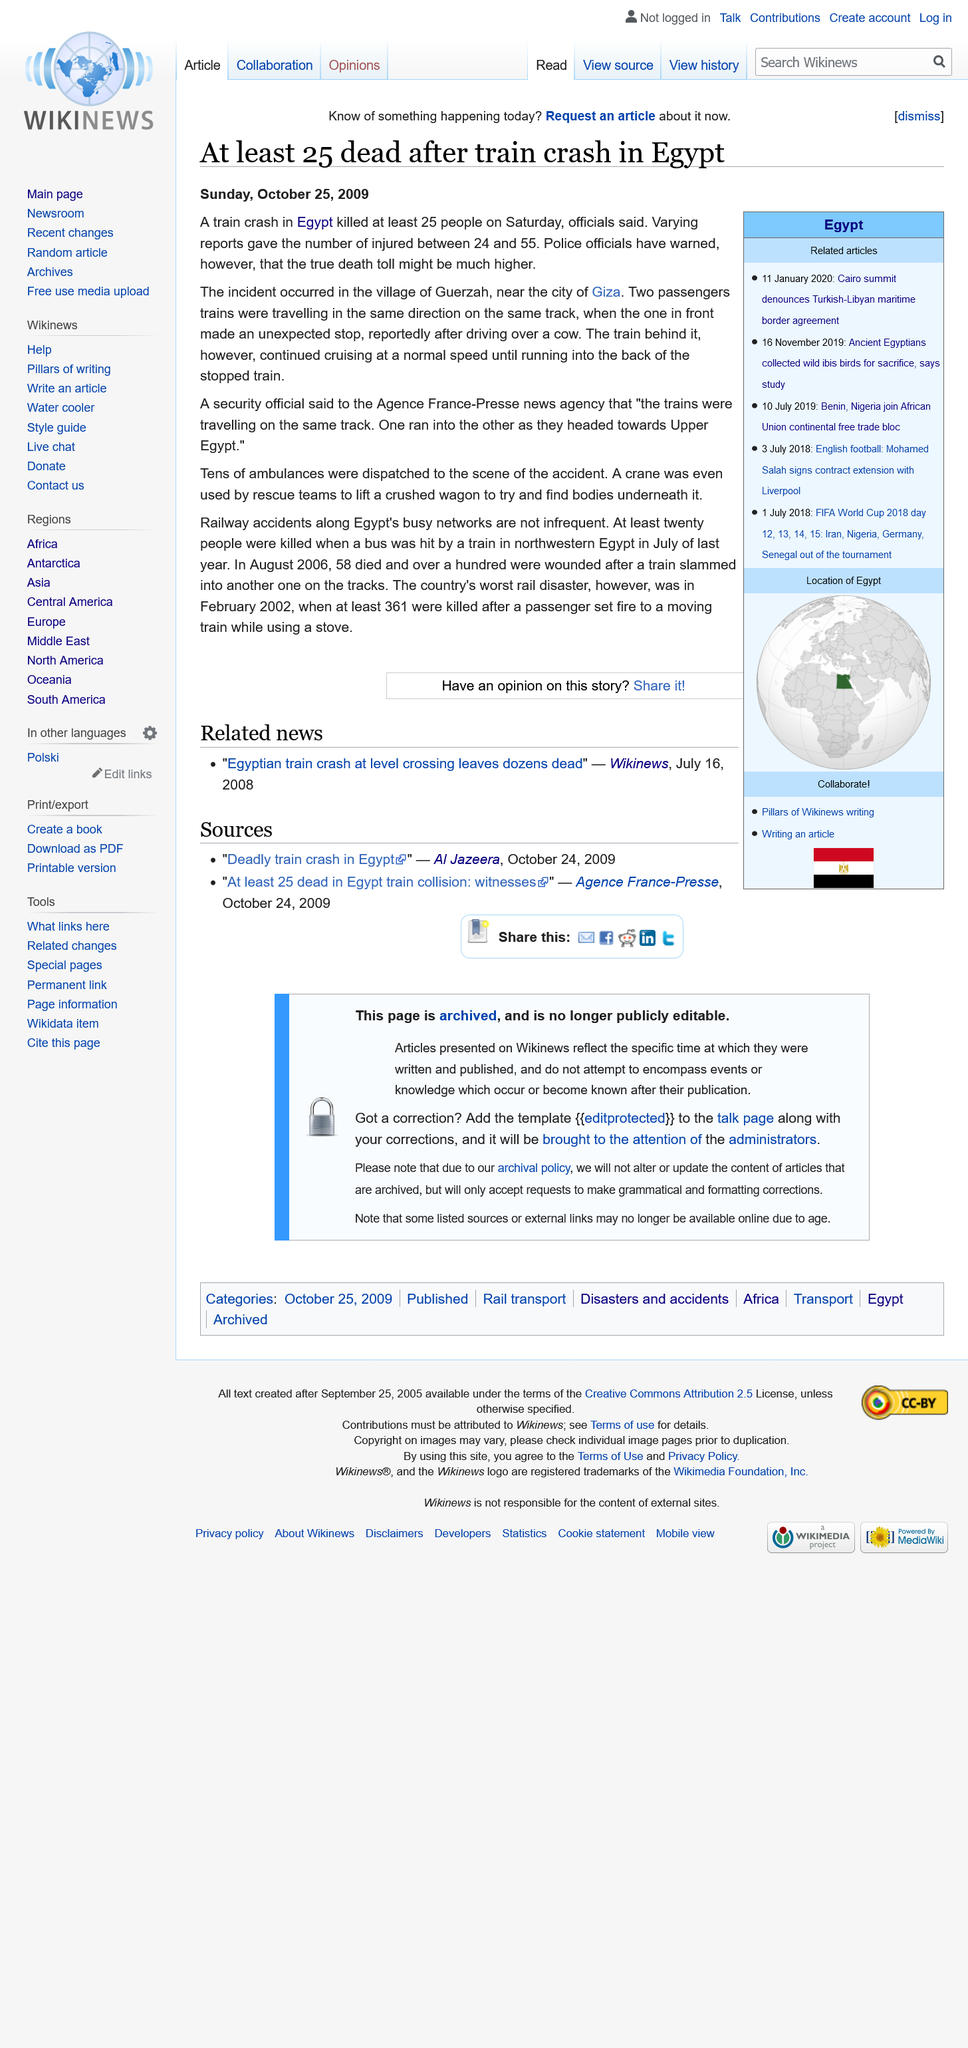Indicate a few pertinent items in this graphic. Many ambulances were dispatched to the scene of the train crash, with tens of ambulances sent to the location of the accident. I declare that the train crash occurred in the village of Guerzah and at least 25 people were killed. 